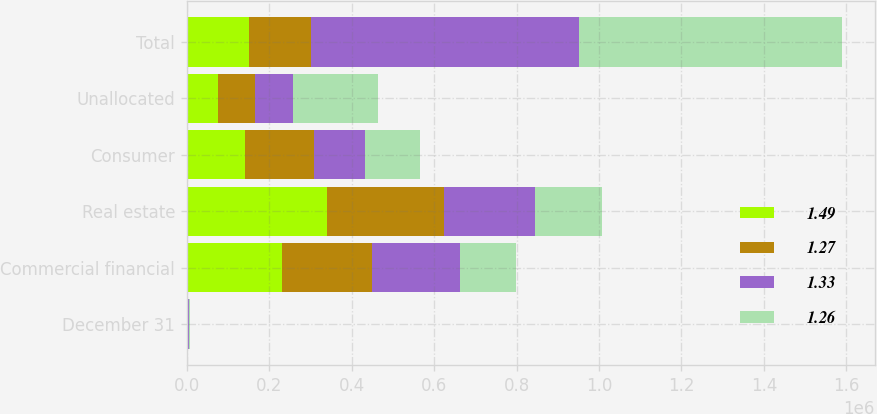Convert chart. <chart><loc_0><loc_0><loc_500><loc_500><stacked_bar_chart><ecel><fcel>December 31<fcel>Commercial financial<fcel>Real estate<fcel>Consumer<fcel>Unallocated<fcel>Total<nl><fcel>1.49<fcel>2008<fcel>231993<fcel>340588<fcel>140571<fcel>74752<fcel>150787<nl><fcel>1.27<fcel>2007<fcel>216833<fcel>283127<fcel>167984<fcel>91495<fcel>150787<nl><fcel>1.33<fcel>2006<fcel>212945<fcel>221747<fcel>124675<fcel>90581<fcel>649948<nl><fcel>1.26<fcel>2005<fcel>136852<fcel>161003<fcel>133541<fcel>206267<fcel>637663<nl></chart> 